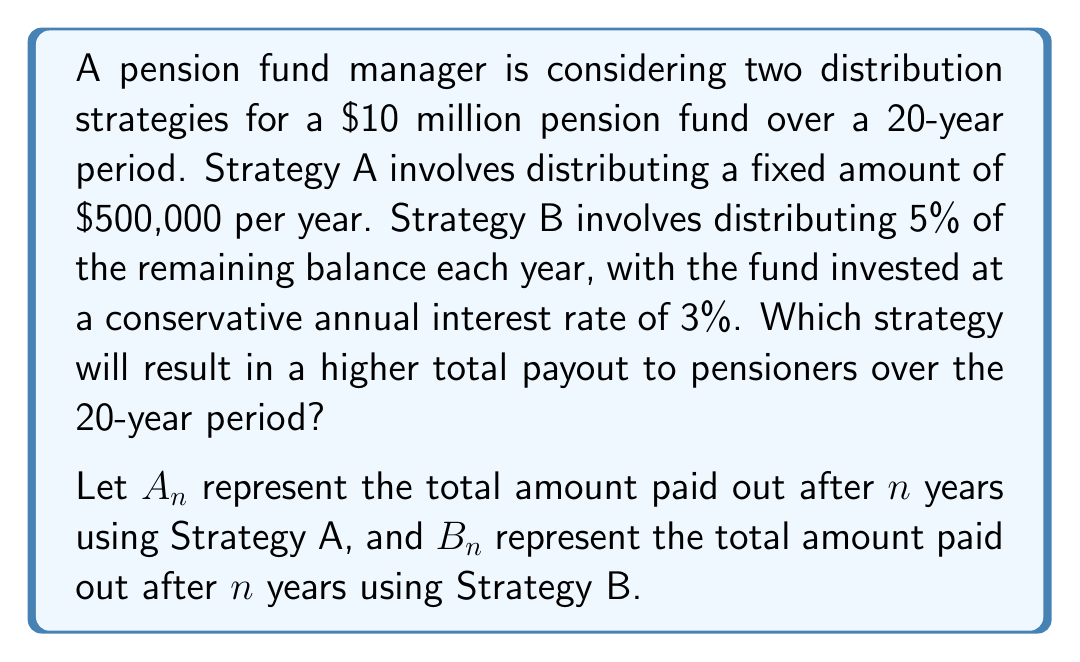Provide a solution to this math problem. To solve this problem, we need to calculate the total payout for each strategy over 20 years.

Strategy A:
This is a straightforward calculation. Each year, a fixed amount of $500,000 is paid out.
$$A_{20} = 500,000 \times 20 = \$10,000,000$$

Strategy B:
This strategy is more complex and requires recursive calculations. Let's define $R_n$ as the remaining balance after $n$ years.

Initial balance: $R_0 = 10,000,000$

For each year $n$ from 1 to 20:
1. Payout: $0.05 \times R_{n-1}$
2. Remaining balance: $R_n = 1.03 \times (R_{n-1} - 0.05 \times R_{n-1}) = 0.9785 \times R_{n-1}$

We can express this as a geometric sequence:
$$R_n = 10,000,000 \times 0.9785^n$$

The payout for year $n$ is:
$$P_n = 0.05 \times R_{n-1} = 500,000 \times 0.9785^{n-1}$$

The total payout after 20 years is the sum of these payouts:

$$B_{20} = \sum_{n=1}^{20} 500,000 \times 0.9785^{n-1}$$

This is a geometric series with first term $a = 500,000$ and common ratio $r = 0.9785$. We can use the formula for the sum of a geometric series:

$$S_n = a\frac{1-r^n}{1-r}$$

Substituting our values:

$$B_{20} = 500,000 \times \frac{1-0.9785^{20}}{1-0.9785} \approx \$9,358,190$$

Comparing the two strategies:
Strategy A total payout: $10,000,000
Strategy B total payout: $9,358,190

Therefore, Strategy A results in a higher total payout over the 20-year period.
Answer: Strategy A, which distributes a fixed amount of $500,000 per year, results in a higher total payout of $10,000,000 over the 20-year period, compared to $9,358,190 for Strategy B. 